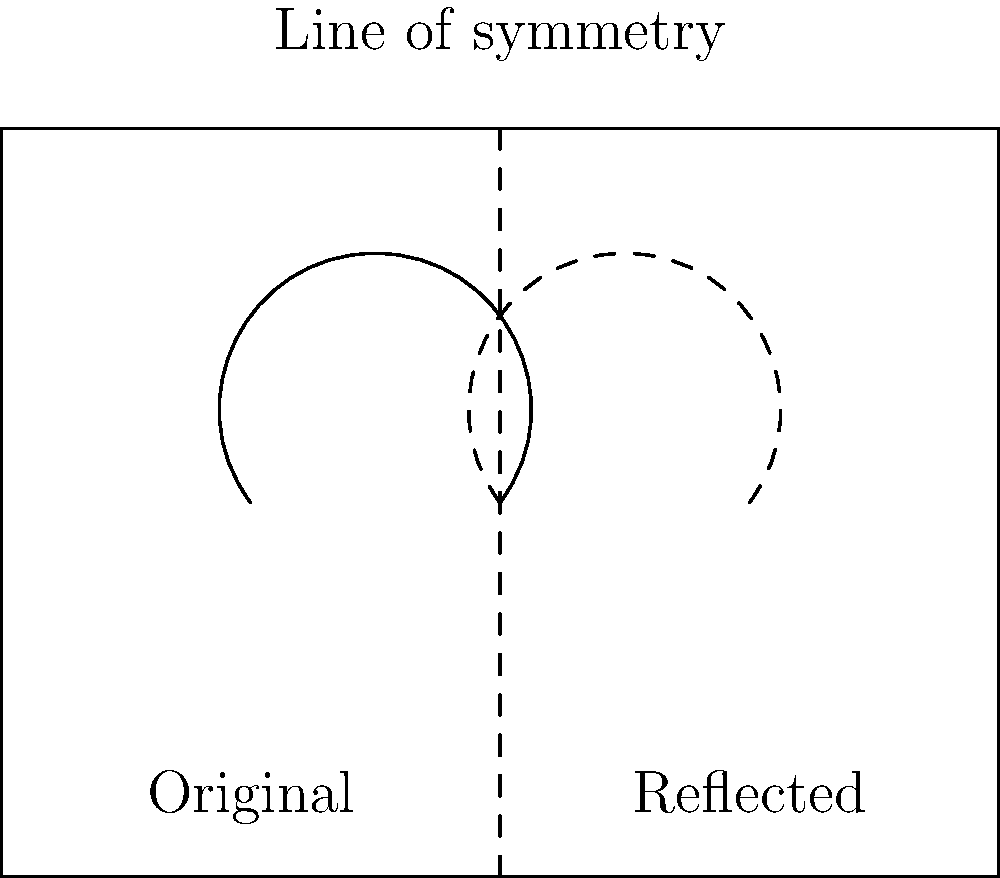In designing a decorative vase, you want to create a mirrored leaf motif. The original leaf design is drawn on the left side of the vase. If you reflect this leaf across the vertical line of symmetry, what transformation would accurately describe the position of the reflected leaf? To solve this problem, let's follow these steps:

1. Identify the line of symmetry: In this case, it's the vertical dashed line running through the center of the vase.

2. Understand reflection: Reflection across a line of symmetry creates a mirror image of the original shape on the opposite side of the line.

3. Analyze the transformation:
   a. Each point of the original leaf will have a corresponding point on the reflected leaf.
   b. The distance of each point on the original leaf from the line of symmetry will be equal to the distance of its corresponding point on the reflected leaf.
   c. The line connecting any point on the original leaf to its corresponding point on the reflected leaf will be perpendicular to the line of symmetry.

4. Describe the transformation mathematically:
   If $(x, y)$ is a point on the original leaf, and the line of symmetry is the vertical line $x = a$, then the reflected point $(x', y')$ can be described by:
   $x' = 2a - x$
   $y' = y$

5. In geometric terms, this transformation can be described as a reflection across the vertical line $x = a$.

Therefore, the transformation that accurately describes the position of the reflected leaf is a reflection across the vertical line of symmetry.
Answer: Reflection across the vertical line of symmetry 